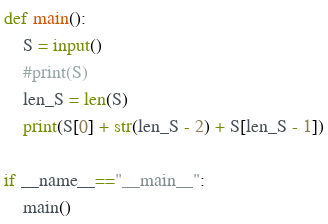Convert code to text. <code><loc_0><loc_0><loc_500><loc_500><_Python_>def main():
    S = input()
    #print(S)
    len_S = len(S)
    print(S[0] + str(len_S - 2) + S[len_S - 1])
     
if __name__=="__main__":
    main()</code> 